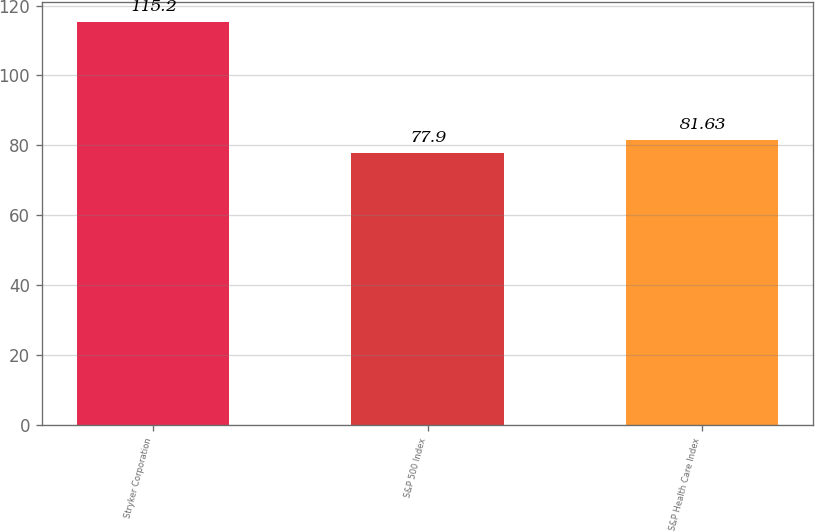Convert chart to OTSL. <chart><loc_0><loc_0><loc_500><loc_500><bar_chart><fcel>Stryker Corporation<fcel>S&P 500 Index<fcel>S&P Health Care Index<nl><fcel>115.2<fcel>77.9<fcel>81.63<nl></chart> 